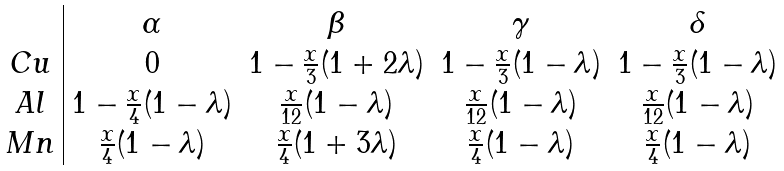<formula> <loc_0><loc_0><loc_500><loc_500>\begin{array} { c | c c c c } & \alpha & \beta & \gamma & \delta \\ C u & 0 & 1 - \frac { x } { 3 } ( 1 + 2 \lambda ) & 1 - \frac { x } { 3 } ( 1 - \lambda ) & 1 - \frac { x } { 3 } ( 1 - \lambda ) \\ A l & 1 - \frac { x } { 4 } ( 1 - \lambda ) & \frac { x } { 1 2 } ( 1 - \lambda ) & \frac { x } { 1 2 } ( 1 - \lambda ) & \frac { x } { 1 2 } ( 1 - \lambda ) \\ M n & \frac { x } { 4 } ( 1 - \lambda ) & \frac { x } { 4 } ( 1 + 3 \lambda ) & \frac { x } { 4 } ( 1 - \lambda ) & \frac { x } { 4 } ( 1 - \lambda ) \\ \end{array}</formula> 